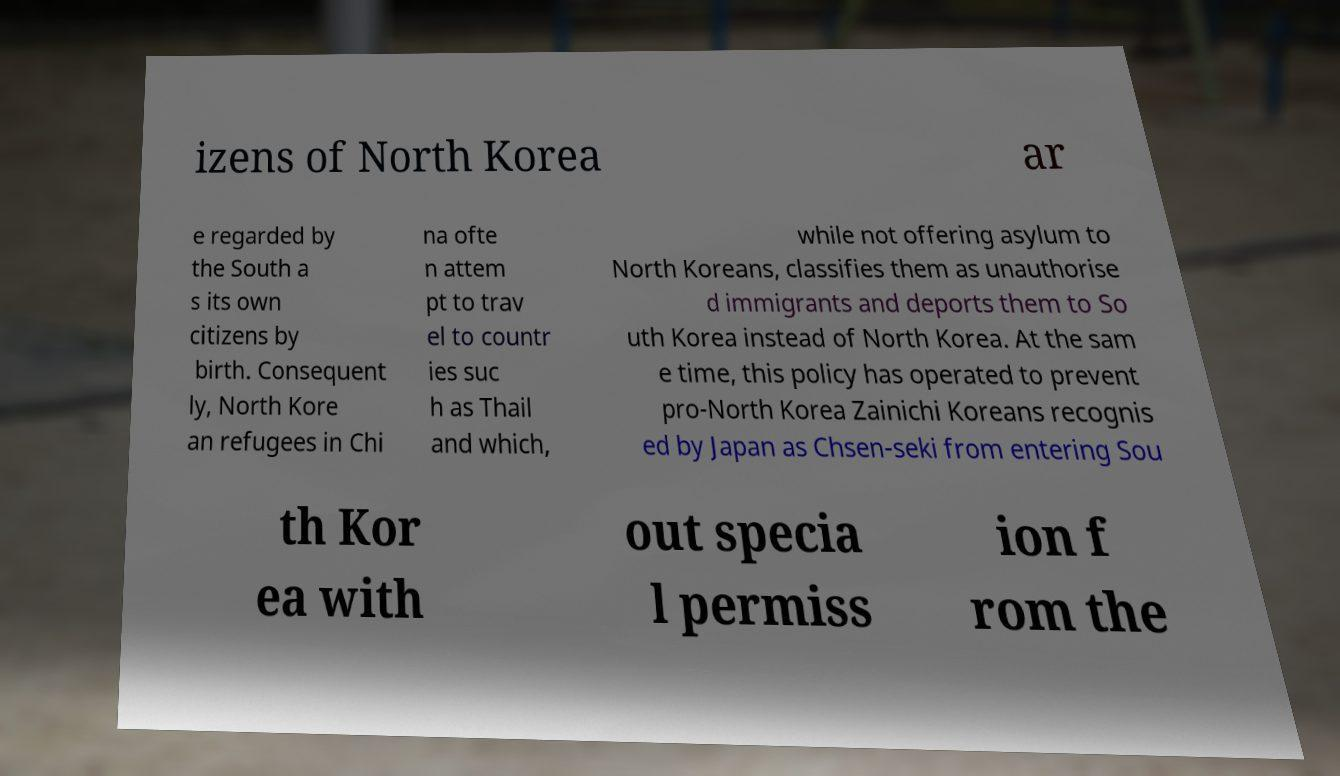Please identify and transcribe the text found in this image. izens of North Korea ar e regarded by the South a s its own citizens by birth. Consequent ly, North Kore an refugees in Chi na ofte n attem pt to trav el to countr ies suc h as Thail and which, while not offering asylum to North Koreans, classifies them as unauthorise d immigrants and deports them to So uth Korea instead of North Korea. At the sam e time, this policy has operated to prevent pro-North Korea Zainichi Koreans recognis ed by Japan as Chsen-seki from entering Sou th Kor ea with out specia l permiss ion f rom the 